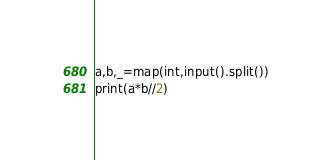<code> <loc_0><loc_0><loc_500><loc_500><_Python_>a,b,_=map(int,input().split())
print(a*b//2)</code> 